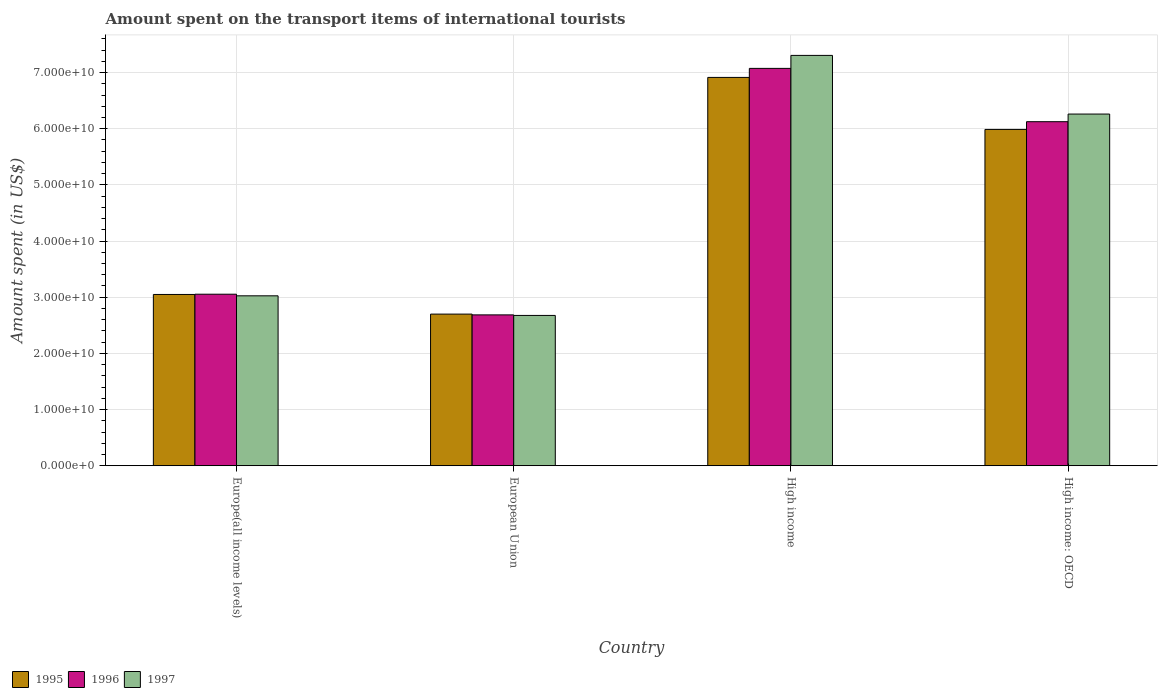How many different coloured bars are there?
Keep it short and to the point. 3. How many groups of bars are there?
Provide a short and direct response. 4. How many bars are there on the 1st tick from the left?
Give a very brief answer. 3. What is the label of the 3rd group of bars from the left?
Provide a succinct answer. High income. In how many cases, is the number of bars for a given country not equal to the number of legend labels?
Provide a short and direct response. 0. What is the amount spent on the transport items of international tourists in 1997 in High income: OECD?
Your response must be concise. 6.26e+1. Across all countries, what is the maximum amount spent on the transport items of international tourists in 1995?
Provide a succinct answer. 6.91e+1. Across all countries, what is the minimum amount spent on the transport items of international tourists in 1997?
Offer a terse response. 2.68e+1. In which country was the amount spent on the transport items of international tourists in 1996 minimum?
Give a very brief answer. European Union. What is the total amount spent on the transport items of international tourists in 1996 in the graph?
Keep it short and to the point. 1.89e+11. What is the difference between the amount spent on the transport items of international tourists in 1997 in European Union and that in High income: OECD?
Your answer should be very brief. -3.59e+1. What is the difference between the amount spent on the transport items of international tourists in 1995 in European Union and the amount spent on the transport items of international tourists in 1997 in High income: OECD?
Your answer should be compact. -3.56e+1. What is the average amount spent on the transport items of international tourists in 1995 per country?
Your answer should be very brief. 4.66e+1. What is the difference between the amount spent on the transport items of international tourists of/in 1995 and amount spent on the transport items of international tourists of/in 1996 in High income: OECD?
Your response must be concise. -1.38e+09. What is the ratio of the amount spent on the transport items of international tourists in 1995 in Europe(all income levels) to that in High income?
Provide a short and direct response. 0.44. Is the amount spent on the transport items of international tourists in 1996 in Europe(all income levels) less than that in High income: OECD?
Keep it short and to the point. Yes. What is the difference between the highest and the second highest amount spent on the transport items of international tourists in 1995?
Offer a terse response. 2.94e+1. What is the difference between the highest and the lowest amount spent on the transport items of international tourists in 1997?
Make the answer very short. 4.63e+1. Is the sum of the amount spent on the transport items of international tourists in 1997 in Europe(all income levels) and High income: OECD greater than the maximum amount spent on the transport items of international tourists in 1995 across all countries?
Your answer should be compact. Yes. How many bars are there?
Your answer should be very brief. 12. Does the graph contain any zero values?
Offer a terse response. No. Where does the legend appear in the graph?
Ensure brevity in your answer.  Bottom left. How are the legend labels stacked?
Provide a short and direct response. Horizontal. What is the title of the graph?
Make the answer very short. Amount spent on the transport items of international tourists. What is the label or title of the Y-axis?
Ensure brevity in your answer.  Amount spent (in US$). What is the Amount spent (in US$) of 1995 in Europe(all income levels)?
Your answer should be compact. 3.05e+1. What is the Amount spent (in US$) in 1996 in Europe(all income levels)?
Give a very brief answer. 3.05e+1. What is the Amount spent (in US$) in 1997 in Europe(all income levels)?
Ensure brevity in your answer.  3.03e+1. What is the Amount spent (in US$) of 1995 in European Union?
Your answer should be compact. 2.70e+1. What is the Amount spent (in US$) of 1996 in European Union?
Offer a very short reply. 2.69e+1. What is the Amount spent (in US$) in 1997 in European Union?
Give a very brief answer. 2.68e+1. What is the Amount spent (in US$) of 1995 in High income?
Keep it short and to the point. 6.91e+1. What is the Amount spent (in US$) of 1996 in High income?
Keep it short and to the point. 7.07e+1. What is the Amount spent (in US$) of 1997 in High income?
Offer a very short reply. 7.31e+1. What is the Amount spent (in US$) in 1995 in High income: OECD?
Your answer should be compact. 5.99e+1. What is the Amount spent (in US$) in 1996 in High income: OECD?
Your response must be concise. 6.12e+1. What is the Amount spent (in US$) in 1997 in High income: OECD?
Offer a terse response. 6.26e+1. Across all countries, what is the maximum Amount spent (in US$) of 1995?
Your answer should be compact. 6.91e+1. Across all countries, what is the maximum Amount spent (in US$) in 1996?
Offer a very short reply. 7.07e+1. Across all countries, what is the maximum Amount spent (in US$) in 1997?
Offer a terse response. 7.31e+1. Across all countries, what is the minimum Amount spent (in US$) in 1995?
Give a very brief answer. 2.70e+1. Across all countries, what is the minimum Amount spent (in US$) in 1996?
Give a very brief answer. 2.69e+1. Across all countries, what is the minimum Amount spent (in US$) in 1997?
Offer a terse response. 2.68e+1. What is the total Amount spent (in US$) in 1995 in the graph?
Ensure brevity in your answer.  1.86e+11. What is the total Amount spent (in US$) of 1996 in the graph?
Your answer should be compact. 1.89e+11. What is the total Amount spent (in US$) in 1997 in the graph?
Your answer should be compact. 1.93e+11. What is the difference between the Amount spent (in US$) in 1995 in Europe(all income levels) and that in European Union?
Your answer should be very brief. 3.50e+09. What is the difference between the Amount spent (in US$) of 1996 in Europe(all income levels) and that in European Union?
Your response must be concise. 3.68e+09. What is the difference between the Amount spent (in US$) of 1997 in Europe(all income levels) and that in European Union?
Provide a succinct answer. 3.49e+09. What is the difference between the Amount spent (in US$) of 1995 in Europe(all income levels) and that in High income?
Offer a very short reply. -3.86e+1. What is the difference between the Amount spent (in US$) of 1996 in Europe(all income levels) and that in High income?
Your response must be concise. -4.02e+1. What is the difference between the Amount spent (in US$) in 1997 in Europe(all income levels) and that in High income?
Ensure brevity in your answer.  -4.28e+1. What is the difference between the Amount spent (in US$) in 1995 in Europe(all income levels) and that in High income: OECD?
Your answer should be very brief. -2.94e+1. What is the difference between the Amount spent (in US$) in 1996 in Europe(all income levels) and that in High income: OECD?
Keep it short and to the point. -3.07e+1. What is the difference between the Amount spent (in US$) of 1997 in Europe(all income levels) and that in High income: OECD?
Give a very brief answer. -3.24e+1. What is the difference between the Amount spent (in US$) in 1995 in European Union and that in High income?
Ensure brevity in your answer.  -4.21e+1. What is the difference between the Amount spent (in US$) of 1996 in European Union and that in High income?
Ensure brevity in your answer.  -4.39e+1. What is the difference between the Amount spent (in US$) in 1997 in European Union and that in High income?
Provide a short and direct response. -4.63e+1. What is the difference between the Amount spent (in US$) in 1995 in European Union and that in High income: OECD?
Your answer should be very brief. -3.29e+1. What is the difference between the Amount spent (in US$) of 1996 in European Union and that in High income: OECD?
Offer a very short reply. -3.44e+1. What is the difference between the Amount spent (in US$) in 1997 in European Union and that in High income: OECD?
Your response must be concise. -3.59e+1. What is the difference between the Amount spent (in US$) in 1995 in High income and that in High income: OECD?
Keep it short and to the point. 9.26e+09. What is the difference between the Amount spent (in US$) of 1996 in High income and that in High income: OECD?
Offer a terse response. 9.49e+09. What is the difference between the Amount spent (in US$) in 1997 in High income and that in High income: OECD?
Keep it short and to the point. 1.04e+1. What is the difference between the Amount spent (in US$) in 1995 in Europe(all income levels) and the Amount spent (in US$) in 1996 in European Union?
Provide a short and direct response. 3.63e+09. What is the difference between the Amount spent (in US$) in 1995 in Europe(all income levels) and the Amount spent (in US$) in 1997 in European Union?
Your answer should be very brief. 3.73e+09. What is the difference between the Amount spent (in US$) of 1996 in Europe(all income levels) and the Amount spent (in US$) of 1997 in European Union?
Provide a short and direct response. 3.78e+09. What is the difference between the Amount spent (in US$) in 1995 in Europe(all income levels) and the Amount spent (in US$) in 1996 in High income?
Provide a succinct answer. -4.02e+1. What is the difference between the Amount spent (in US$) of 1995 in Europe(all income levels) and the Amount spent (in US$) of 1997 in High income?
Your answer should be very brief. -4.26e+1. What is the difference between the Amount spent (in US$) in 1996 in Europe(all income levels) and the Amount spent (in US$) in 1997 in High income?
Offer a terse response. -4.25e+1. What is the difference between the Amount spent (in US$) in 1995 in Europe(all income levels) and the Amount spent (in US$) in 1996 in High income: OECD?
Provide a short and direct response. -3.08e+1. What is the difference between the Amount spent (in US$) in 1995 in Europe(all income levels) and the Amount spent (in US$) in 1997 in High income: OECD?
Keep it short and to the point. -3.21e+1. What is the difference between the Amount spent (in US$) in 1996 in Europe(all income levels) and the Amount spent (in US$) in 1997 in High income: OECD?
Offer a terse response. -3.21e+1. What is the difference between the Amount spent (in US$) of 1995 in European Union and the Amount spent (in US$) of 1996 in High income?
Provide a succinct answer. -4.37e+1. What is the difference between the Amount spent (in US$) in 1995 in European Union and the Amount spent (in US$) in 1997 in High income?
Make the answer very short. -4.61e+1. What is the difference between the Amount spent (in US$) in 1996 in European Union and the Amount spent (in US$) in 1997 in High income?
Give a very brief answer. -4.62e+1. What is the difference between the Amount spent (in US$) of 1995 in European Union and the Amount spent (in US$) of 1996 in High income: OECD?
Keep it short and to the point. -3.43e+1. What is the difference between the Amount spent (in US$) in 1995 in European Union and the Amount spent (in US$) in 1997 in High income: OECD?
Offer a terse response. -3.56e+1. What is the difference between the Amount spent (in US$) of 1996 in European Union and the Amount spent (in US$) of 1997 in High income: OECD?
Your answer should be very brief. -3.58e+1. What is the difference between the Amount spent (in US$) of 1995 in High income and the Amount spent (in US$) of 1996 in High income: OECD?
Ensure brevity in your answer.  7.88e+09. What is the difference between the Amount spent (in US$) of 1995 in High income and the Amount spent (in US$) of 1997 in High income: OECD?
Your answer should be compact. 6.52e+09. What is the difference between the Amount spent (in US$) in 1996 in High income and the Amount spent (in US$) in 1997 in High income: OECD?
Offer a terse response. 8.13e+09. What is the average Amount spent (in US$) of 1995 per country?
Provide a succinct answer. 4.66e+1. What is the average Amount spent (in US$) of 1996 per country?
Offer a very short reply. 4.73e+1. What is the average Amount spent (in US$) in 1997 per country?
Provide a short and direct response. 4.82e+1. What is the difference between the Amount spent (in US$) in 1995 and Amount spent (in US$) in 1996 in Europe(all income levels)?
Your answer should be very brief. -4.44e+07. What is the difference between the Amount spent (in US$) in 1995 and Amount spent (in US$) in 1997 in Europe(all income levels)?
Keep it short and to the point. 2.41e+08. What is the difference between the Amount spent (in US$) of 1996 and Amount spent (in US$) of 1997 in Europe(all income levels)?
Provide a succinct answer. 2.85e+08. What is the difference between the Amount spent (in US$) in 1995 and Amount spent (in US$) in 1996 in European Union?
Offer a terse response. 1.37e+08. What is the difference between the Amount spent (in US$) of 1995 and Amount spent (in US$) of 1997 in European Union?
Your answer should be very brief. 2.35e+08. What is the difference between the Amount spent (in US$) in 1996 and Amount spent (in US$) in 1997 in European Union?
Provide a succinct answer. 9.81e+07. What is the difference between the Amount spent (in US$) in 1995 and Amount spent (in US$) in 1996 in High income?
Give a very brief answer. -1.61e+09. What is the difference between the Amount spent (in US$) of 1995 and Amount spent (in US$) of 1997 in High income?
Provide a succinct answer. -3.92e+09. What is the difference between the Amount spent (in US$) of 1996 and Amount spent (in US$) of 1997 in High income?
Your response must be concise. -2.31e+09. What is the difference between the Amount spent (in US$) in 1995 and Amount spent (in US$) in 1996 in High income: OECD?
Offer a terse response. -1.38e+09. What is the difference between the Amount spent (in US$) in 1995 and Amount spent (in US$) in 1997 in High income: OECD?
Provide a short and direct response. -2.74e+09. What is the difference between the Amount spent (in US$) in 1996 and Amount spent (in US$) in 1997 in High income: OECD?
Make the answer very short. -1.36e+09. What is the ratio of the Amount spent (in US$) in 1995 in Europe(all income levels) to that in European Union?
Make the answer very short. 1.13. What is the ratio of the Amount spent (in US$) in 1996 in Europe(all income levels) to that in European Union?
Provide a short and direct response. 1.14. What is the ratio of the Amount spent (in US$) of 1997 in Europe(all income levels) to that in European Union?
Your answer should be very brief. 1.13. What is the ratio of the Amount spent (in US$) of 1995 in Europe(all income levels) to that in High income?
Make the answer very short. 0.44. What is the ratio of the Amount spent (in US$) of 1996 in Europe(all income levels) to that in High income?
Offer a terse response. 0.43. What is the ratio of the Amount spent (in US$) of 1997 in Europe(all income levels) to that in High income?
Your answer should be very brief. 0.41. What is the ratio of the Amount spent (in US$) of 1995 in Europe(all income levels) to that in High income: OECD?
Ensure brevity in your answer.  0.51. What is the ratio of the Amount spent (in US$) of 1996 in Europe(all income levels) to that in High income: OECD?
Ensure brevity in your answer.  0.5. What is the ratio of the Amount spent (in US$) of 1997 in Europe(all income levels) to that in High income: OECD?
Make the answer very short. 0.48. What is the ratio of the Amount spent (in US$) of 1995 in European Union to that in High income?
Your response must be concise. 0.39. What is the ratio of the Amount spent (in US$) of 1996 in European Union to that in High income?
Your answer should be compact. 0.38. What is the ratio of the Amount spent (in US$) in 1997 in European Union to that in High income?
Provide a succinct answer. 0.37. What is the ratio of the Amount spent (in US$) of 1995 in European Union to that in High income: OECD?
Offer a very short reply. 0.45. What is the ratio of the Amount spent (in US$) in 1996 in European Union to that in High income: OECD?
Your response must be concise. 0.44. What is the ratio of the Amount spent (in US$) of 1997 in European Union to that in High income: OECD?
Your response must be concise. 0.43. What is the ratio of the Amount spent (in US$) in 1995 in High income to that in High income: OECD?
Offer a terse response. 1.15. What is the ratio of the Amount spent (in US$) of 1996 in High income to that in High income: OECD?
Offer a very short reply. 1.15. What is the ratio of the Amount spent (in US$) of 1997 in High income to that in High income: OECD?
Make the answer very short. 1.17. What is the difference between the highest and the second highest Amount spent (in US$) in 1995?
Provide a succinct answer. 9.26e+09. What is the difference between the highest and the second highest Amount spent (in US$) in 1996?
Offer a terse response. 9.49e+09. What is the difference between the highest and the second highest Amount spent (in US$) in 1997?
Ensure brevity in your answer.  1.04e+1. What is the difference between the highest and the lowest Amount spent (in US$) in 1995?
Provide a short and direct response. 4.21e+1. What is the difference between the highest and the lowest Amount spent (in US$) of 1996?
Provide a short and direct response. 4.39e+1. What is the difference between the highest and the lowest Amount spent (in US$) of 1997?
Keep it short and to the point. 4.63e+1. 